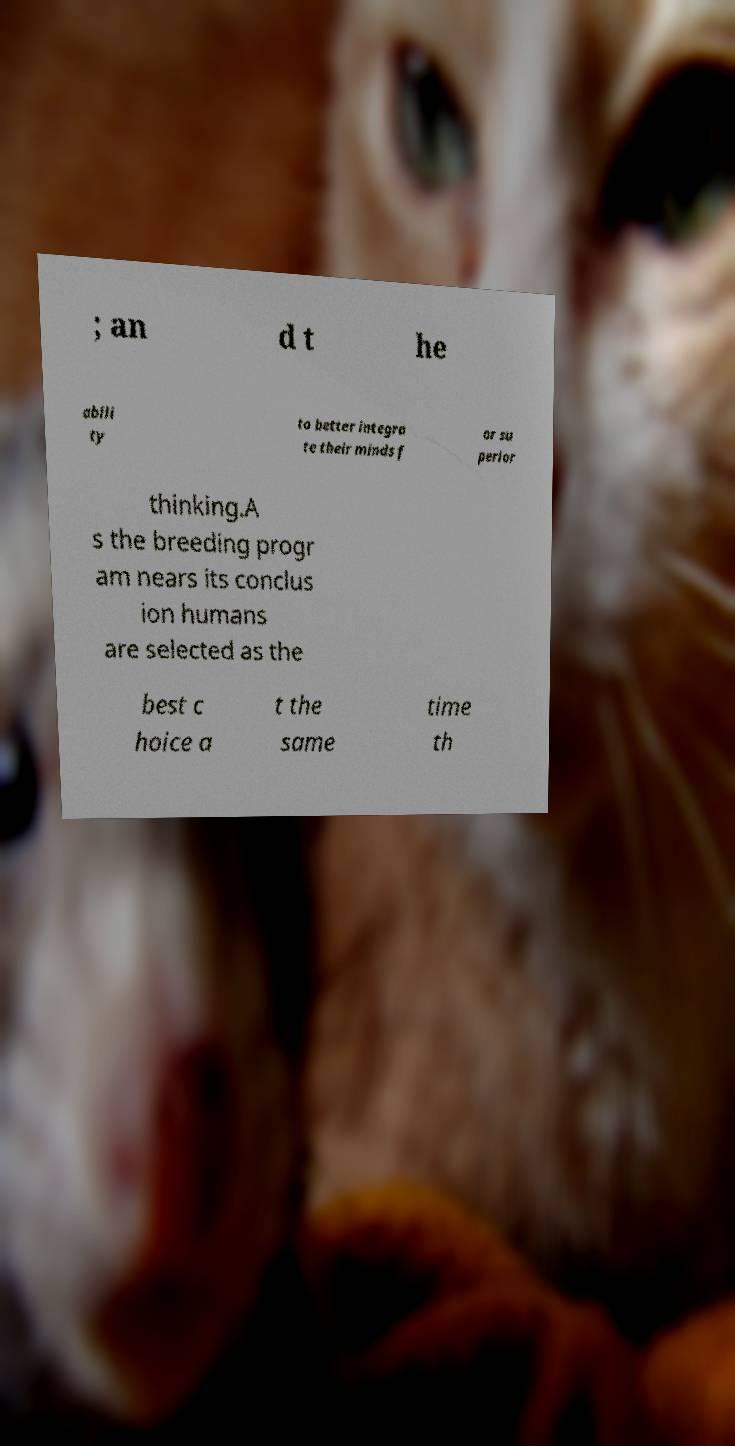Please read and relay the text visible in this image. What does it say? ; an d t he abili ty to better integra te their minds f or su perior thinking.A s the breeding progr am nears its conclus ion humans are selected as the best c hoice a t the same time th 